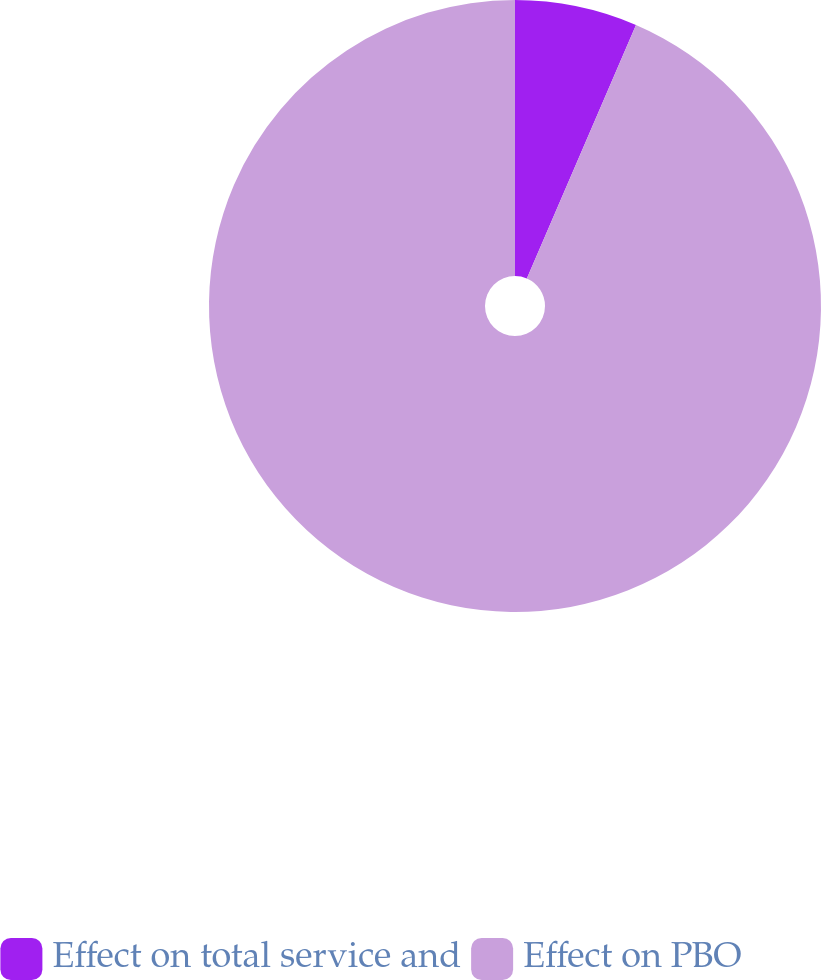<chart> <loc_0><loc_0><loc_500><loc_500><pie_chart><fcel>Effect on total service and<fcel>Effect on PBO<nl><fcel>6.47%<fcel>93.53%<nl></chart> 